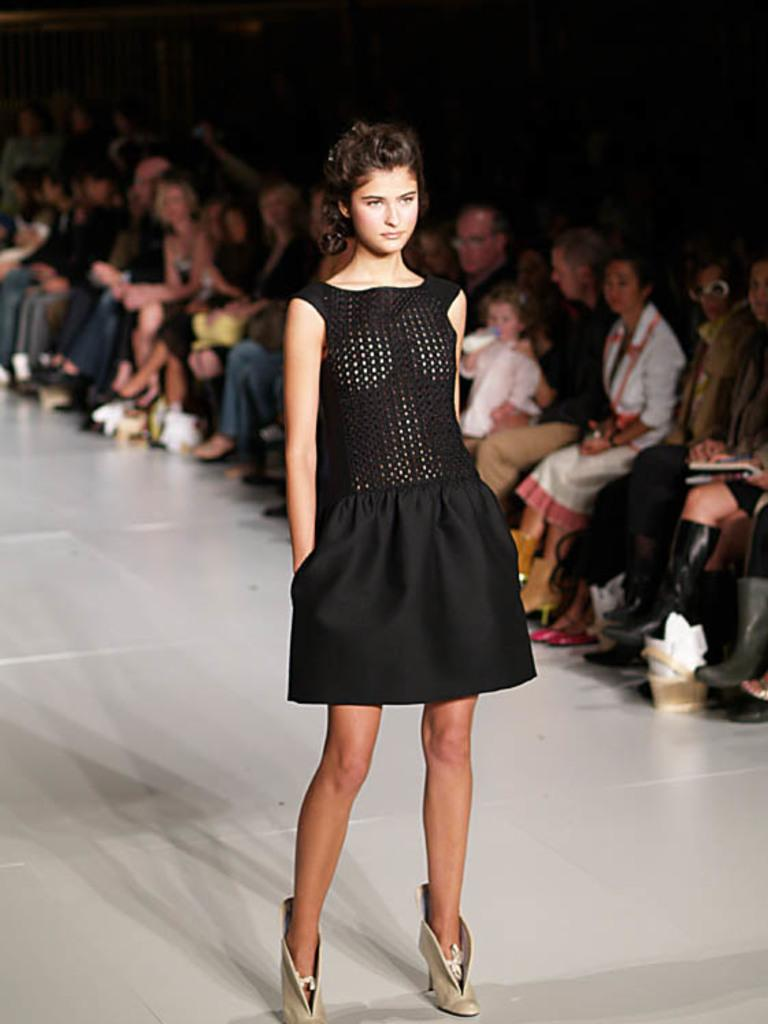Who is the main subject in the image? There is a woman standing in the center of the image. What is the woman standing on? The woman is standing on the floor. What can be seen in the background of the image? There are persons sitting in the background of the image. What are the persons sitting on? The persons are sitting on chairs. What type of animal is sitting next to the woman in the image? There is no animal present in the image; it only features the woman standing and the persons sitting on chairs in the background. 